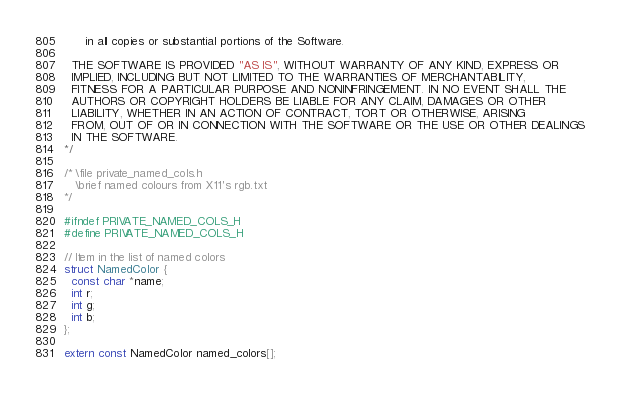Convert code to text. <code><loc_0><loc_0><loc_500><loc_500><_C_>      in all copies or substantial portions of the Software.

  THE SOFTWARE IS PROVIDED "AS IS", WITHOUT WARRANTY OF ANY KIND, EXPRESS OR
  IMPLIED, INCLUDING BUT NOT LIMITED TO THE WARRANTIES OF MERCHANTABILITY,
  FITNESS FOR A PARTICULAR PURPOSE AND NONINFRINGEMENT. IN NO EVENT SHALL THE
  AUTHORS OR COPYRIGHT HOLDERS BE LIABLE FOR ANY CLAIM, DAMAGES OR OTHER
  LIABILITY, WHETHER IN AN ACTION OF CONTRACT, TORT OR OTHERWISE, ARISING
  FROM, OUT OF OR IN CONNECTION WITH THE SOFTWARE OR THE USE OR OTHER DEALINGS
  IN THE SOFTWARE.
*/

/* \file private_named_cols.h
   \brief named colours from X11's rgb.txt
*/

#ifndef PRIVATE_NAMED_COLS_H
#define PRIVATE_NAMED_COLS_H

// Item in the list of named colors
struct NamedColor {
  const char *name;
  int r;
  int g;
  int b;
};

extern const NamedColor named_colors[];
</code> 